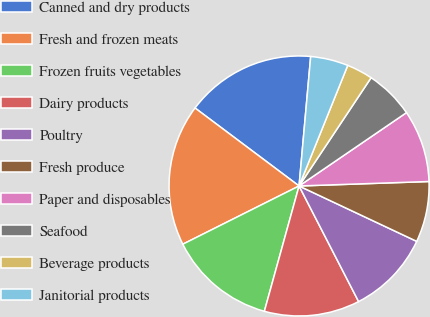Convert chart to OTSL. <chart><loc_0><loc_0><loc_500><loc_500><pie_chart><fcel>Canned and dry products<fcel>Fresh and frozen meats<fcel>Frozen fruits vegetables<fcel>Dairy products<fcel>Poultry<fcel>Fresh produce<fcel>Paper and disposables<fcel>Seafood<fcel>Beverage products<fcel>Janitorial products<nl><fcel>16.19%<fcel>17.63%<fcel>13.31%<fcel>11.87%<fcel>10.43%<fcel>7.55%<fcel>8.99%<fcel>6.12%<fcel>3.24%<fcel>4.68%<nl></chart> 